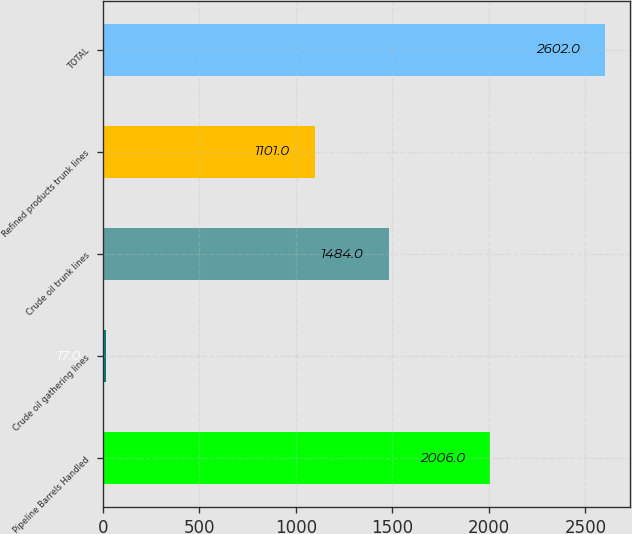<chart> <loc_0><loc_0><loc_500><loc_500><bar_chart><fcel>Pipeline Barrels Handled<fcel>Crude oil gathering lines<fcel>Crude oil trunk lines<fcel>Refined products trunk lines<fcel>TOTAL<nl><fcel>2006<fcel>17<fcel>1484<fcel>1101<fcel>2602<nl></chart> 